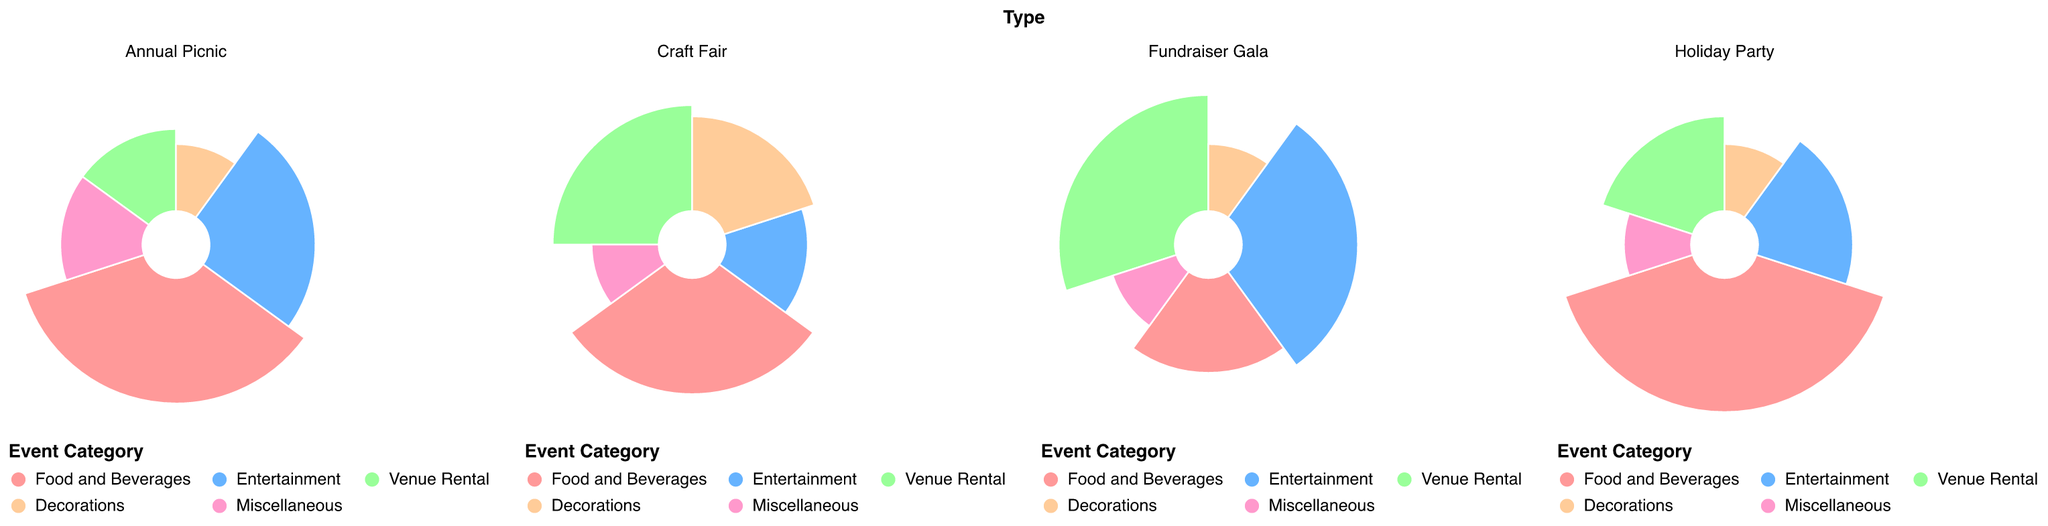What percentage of the Annual Picnic's budget is allocated to Food and Beverages? Locate the 'Annual Picnic' subplot and find the segment labeled 'Food and Beverages'. The tooltip or the color-coded legend will indicate the percentage as 35.
Answer: 35% Which event has the highest percentage allocated to Venue Rental? Compare the Venue Rental percentages across each subplot. For the Annual Picnic, it's 15%; for the Holiday Party, it's 20%; for the Craft Fair, it's 25%; and for the Fundraiser Gala, it's 30%. The highest percentage is for the Fundraiser Gala.
Answer: Fundraiser Gala What are the total budgets allocated to Entertainment across all events? Add up the Entertainment percentages for each event: Annual Picnic (25) + Holiday Party (20) + Craft Fair (15) + Fundraiser Gala (30). The total is 25 + 20 + 15 + 30 = 90.
Answer: 90% Which event has the largest budget allocation for Miscellaneous expenses, and what is the value? Check the Miscellaneous percentage for each event. For the Annual Picnic, it's 15%; for the Holiday Party, it's 10%; for the Craft Fair, it's 10%; and for the Fundraiser Gala, it's 10%. The largest allocation is for the Annual Picnic at 15%.
Answer: Annual Picnic, 15% How do the allocations for Decorations compare between the Craft Fair and the Holiday Party? Look at the Decoration percentages for Craft Fair (20%) and Holiday Party (10%). The Craft Fair allocates more budget to Decorations than the Holiday Party by 10%.
Answer: Craft Fair allocates 10% more For which event is the smallest percentage allocated to Food and Beverages? Compare the Food and Beverage percentages: Annual Picnic (35%), Holiday Party (40%), Craft Fair (30%), Fundraiser Gala (20%). The smallest allocation is for the Fundraiser Gala.
Answer: Fundraiser Gala Which event has the most balanced budget allocation across all categories? Observe the subplots to see which event has the most evenly distributed segments. The Annual Picnic has a relatively balanced budget compared to others since the segments have moderate differences: Food and Beverages (35%), Entertainment (25%), Venue Rental (15%), Decorations (10%), Miscellaneous (15%).
Answer: Annual Picnic 